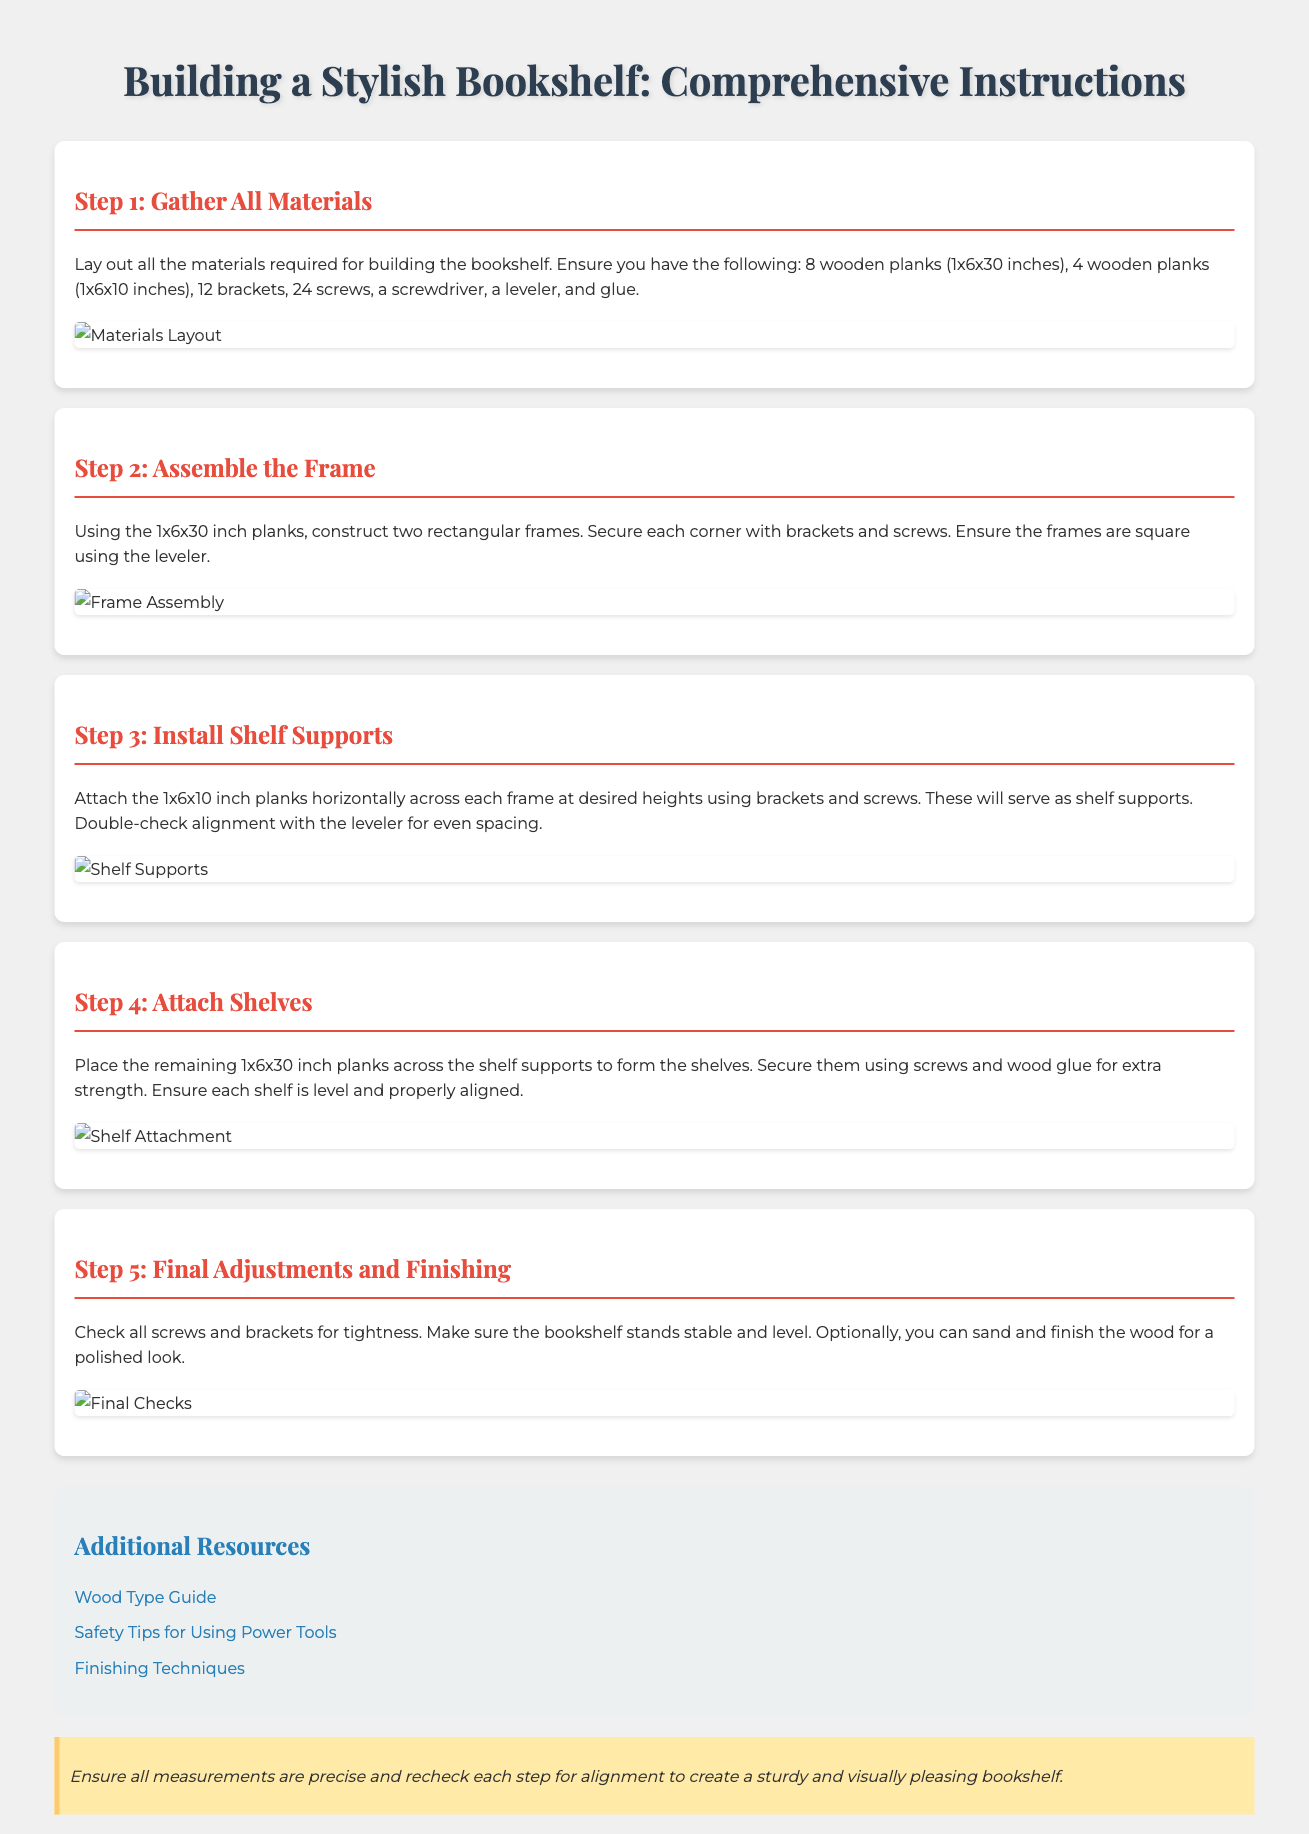What tools are required to build the bookshelf? The prompt mentions the necessary tools for construction. They include a screwdriver, a leveler, and glue.
Answer: screwdriver, leveler, glue How many wooden planks of size 1x6x30 inches are needed? The document specifies the quantities of each type of material required. For this size, 8 wooden planks are needed.
Answer: 8 What is the purpose of the 1x6x10 inch planks? The role of these shorter planks is clearly stated as supporting the shelves.
Answer: shelf supports What should be checked for tightness before finishing? The document advises checking the screws and brackets before completing the assembly.
Answer: screws and brackets What additional resources are provided in the document? The resources section lists links that provide further information on wood types, safety tips, and finishing techniques.
Answer: Wood Type Guide, Safety Tips for Using Power Tools, Finishing Techniques What should be done for extra strength when attaching shelves? For added durability, the instructions suggest using screws and wood glue together.
Answer: screws and wood glue How are the frames constructed in Step 2? The instruction details how to use the longer planks to create rectangular frames, secured at each corner with brackets.
Answer: rectangular frames What visual element supports the assembly instructions? The document contains visual cues such as images accompanying each step to aid in understanding.
Answer: images 